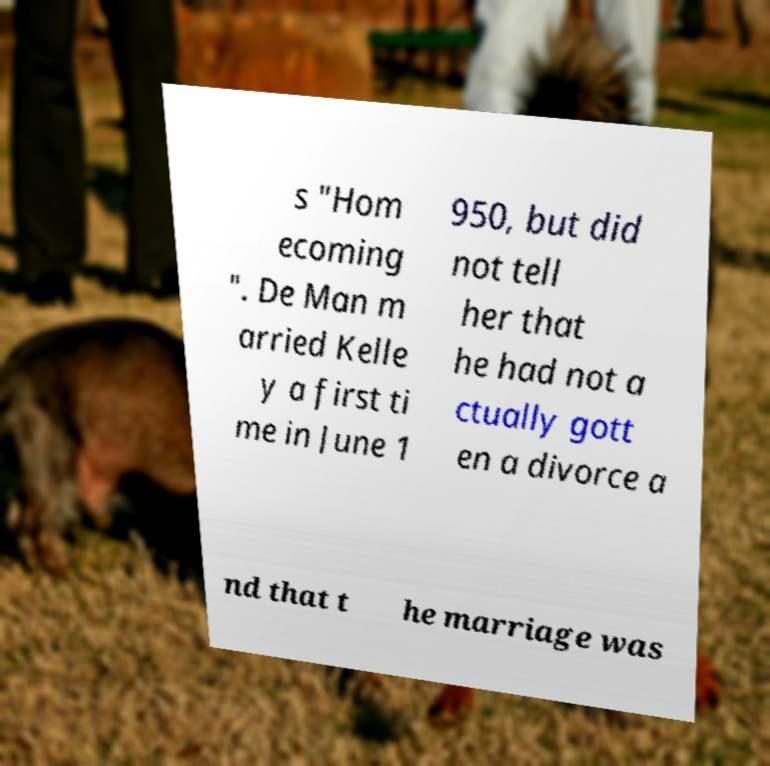For documentation purposes, I need the text within this image transcribed. Could you provide that? s "Hom ecoming ". De Man m arried Kelle y a first ti me in June 1 950, but did not tell her that he had not a ctually gott en a divorce a nd that t he marriage was 